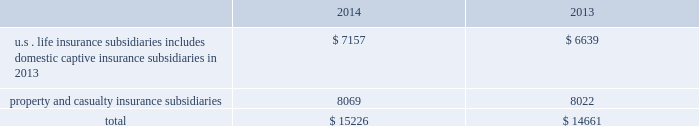The agencies consider many factors in determining the final rating of an insurance company .
One consideration is the relative level of statutory surplus necessary to support the business written .
Statutory surplus represents the capital of the insurance company reported in accordance with accounting practices prescribed by the applicable state insurance department .
See part i , item 1a .
Risk factors 2014 201cdowngrades in our financial strength or credit ratings , which may make our products less attractive , could increase our cost of capital and inhibit our ability to refinance our debt , which would have a material adverse effect on our business , financial condition , results of operations and liquidity . 201d statutory surplus the table below sets forth statutory surplus for the company 2019s insurance companies as of december 31 , 2014 and 2013: .
Statutory capital and surplus for the u.s .
Life insurance subsidiaries , including domestic captive insurance subsidiaries in 2013 , increased by $ 518 , primarily due to variable annuity surplus impacts of $ 788 , net income from non-variable annuity business of $ 187 , increases in unrealized gains from other invested assets carrying values of $ 138 , partially offset by returns of capital of $ 500 , and changes in reserves on account of change in valuation basis of $ 100 .
Effective april 30 , 2014 the last domestic captive ceased operations .
Statutory capital and surplus for the property and casualty insurance increased by $ 47 , primarily due to statutory net income of $ 1.1 billion , and unrealized gains on investments of $ 1.4 billion , largely offset by dividends to the hfsg holding company of $ 2.5 billion .
The company also held regulatory capital and surplus for its former operations in japan until the sale of those operations on june 30 , 2014 .
Under the accounting practices and procedures governed by japanese regulatory authorities , the company 2019s statutory capital and surplus was $ 1.2 billion as of december 31 , 2013. .
What is the growth rate in balance of u.s . life insurance subsidiaries from 2013 to 2014? 
Computations: (7157 - 6639)
Answer: 518.0. The agencies consider many factors in determining the final rating of an insurance company .
One consideration is the relative level of statutory surplus necessary to support the business written .
Statutory surplus represents the capital of the insurance company reported in accordance with accounting practices prescribed by the applicable state insurance department .
See part i , item 1a .
Risk factors 2014 201cdowngrades in our financial strength or credit ratings , which may make our products less attractive , could increase our cost of capital and inhibit our ability to refinance our debt , which would have a material adverse effect on our business , financial condition , results of operations and liquidity . 201d statutory surplus the table below sets forth statutory surplus for the company 2019s insurance companies as of december 31 , 2014 and 2013: .
Statutory capital and surplus for the u.s .
Life insurance subsidiaries , including domestic captive insurance subsidiaries in 2013 , increased by $ 518 , primarily due to variable annuity surplus impacts of $ 788 , net income from non-variable annuity business of $ 187 , increases in unrealized gains from other invested assets carrying values of $ 138 , partially offset by returns of capital of $ 500 , and changes in reserves on account of change in valuation basis of $ 100 .
Effective april 30 , 2014 the last domestic captive ceased operations .
Statutory capital and surplus for the property and casualty insurance increased by $ 47 , primarily due to statutory net income of $ 1.1 billion , and unrealized gains on investments of $ 1.4 billion , largely offset by dividends to the hfsg holding company of $ 2.5 billion .
The company also held regulatory capital and surplus for its former operations in japan until the sale of those operations on june 30 , 2014 .
Under the accounting practices and procedures governed by japanese regulatory authorities , the company 2019s statutory capital and surplus was $ 1.2 billion as of december 31 , 2013. .
What was the average statutory surplus for the company 2019s insurance companies for u.s . life insurance subsidiaries including domestic captive insurance subsidiaries from 2012 to 2013? 
Computations: ((7157 + 6639) / 2)
Answer: 6898.0. 